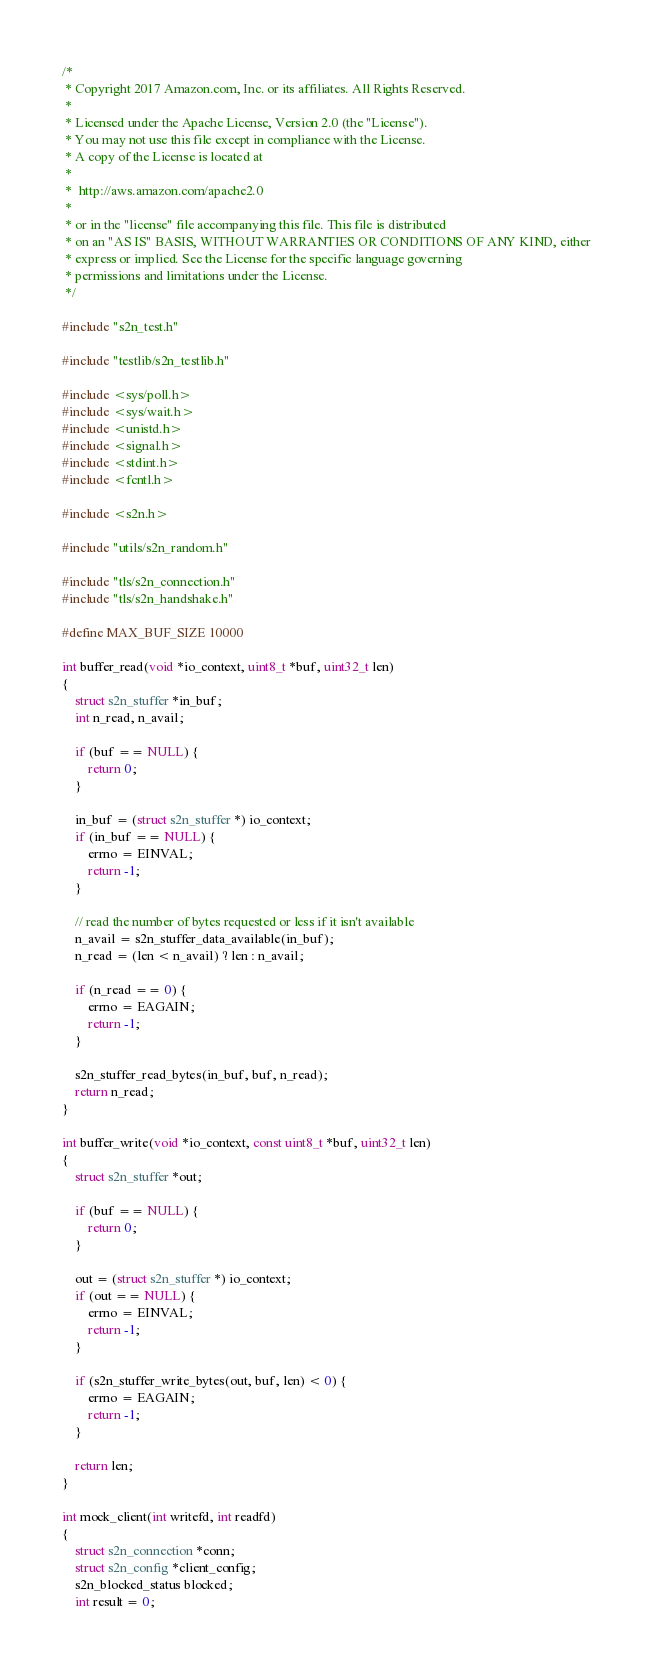Convert code to text. <code><loc_0><loc_0><loc_500><loc_500><_C_>/*
 * Copyright 2017 Amazon.com, Inc. or its affiliates. All Rights Reserved.
 *
 * Licensed under the Apache License, Version 2.0 (the "License").
 * You may not use this file except in compliance with the License.
 * A copy of the License is located at
 *
 *  http://aws.amazon.com/apache2.0
 *
 * or in the "license" file accompanying this file. This file is distributed
 * on an "AS IS" BASIS, WITHOUT WARRANTIES OR CONDITIONS OF ANY KIND, either
 * express or implied. See the License for the specific language governing
 * permissions and limitations under the License.
 */

#include "s2n_test.h"

#include "testlib/s2n_testlib.h"

#include <sys/poll.h>
#include <sys/wait.h>
#include <unistd.h>
#include <signal.h>
#include <stdint.h>
#include <fcntl.h>

#include <s2n.h>

#include "utils/s2n_random.h"

#include "tls/s2n_connection.h"
#include "tls/s2n_handshake.h"

#define MAX_BUF_SIZE 10000

int buffer_read(void *io_context, uint8_t *buf, uint32_t len)
{
    struct s2n_stuffer *in_buf;
    int n_read, n_avail;
    
    if (buf == NULL) {
        return 0;
    }

    in_buf = (struct s2n_stuffer *) io_context;
    if (in_buf == NULL) {
        errno = EINVAL;
        return -1;
    }
   
    // read the number of bytes requested or less if it isn't available
    n_avail = s2n_stuffer_data_available(in_buf);
    n_read = (len < n_avail) ? len : n_avail;

    if (n_read == 0) {
        errno = EAGAIN;
        return -1;
    }

    s2n_stuffer_read_bytes(in_buf, buf, n_read);
    return n_read;
}

int buffer_write(void *io_context, const uint8_t *buf, uint32_t len)
{
    struct s2n_stuffer *out;

    if (buf == NULL) {
        return 0;
    }
    
    out = (struct s2n_stuffer *) io_context;
    if (out == NULL) {
        errno = EINVAL;
        return -1;
    }

    if (s2n_stuffer_write_bytes(out, buf, len) < 0) {
        errno = EAGAIN;
        return -1;
    }

    return len;
}

int mock_client(int writefd, int readfd)
{
    struct s2n_connection *conn;
    struct s2n_config *client_config;
    s2n_blocked_status blocked;
    int result = 0;
</code> 